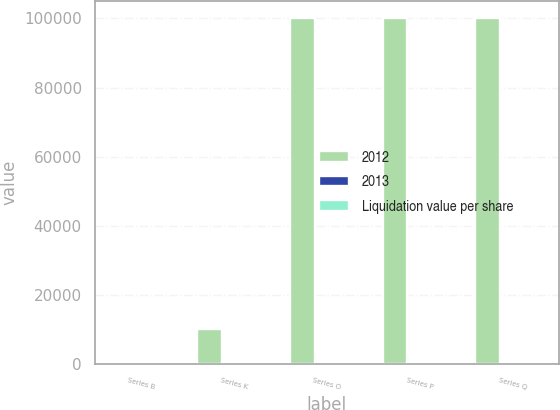Convert chart. <chart><loc_0><loc_0><loc_500><loc_500><stacked_bar_chart><ecel><fcel>Series B<fcel>Series K<fcel>Series O<fcel>Series P<fcel>Series Q<nl><fcel>2012<fcel>40<fcel>10000<fcel>100000<fcel>100000<fcel>100000<nl><fcel>2013<fcel>1<fcel>50<fcel>10<fcel>15<fcel>5<nl><fcel>Liquidation value per share<fcel>1<fcel>50<fcel>10<fcel>15<fcel>5<nl></chart> 